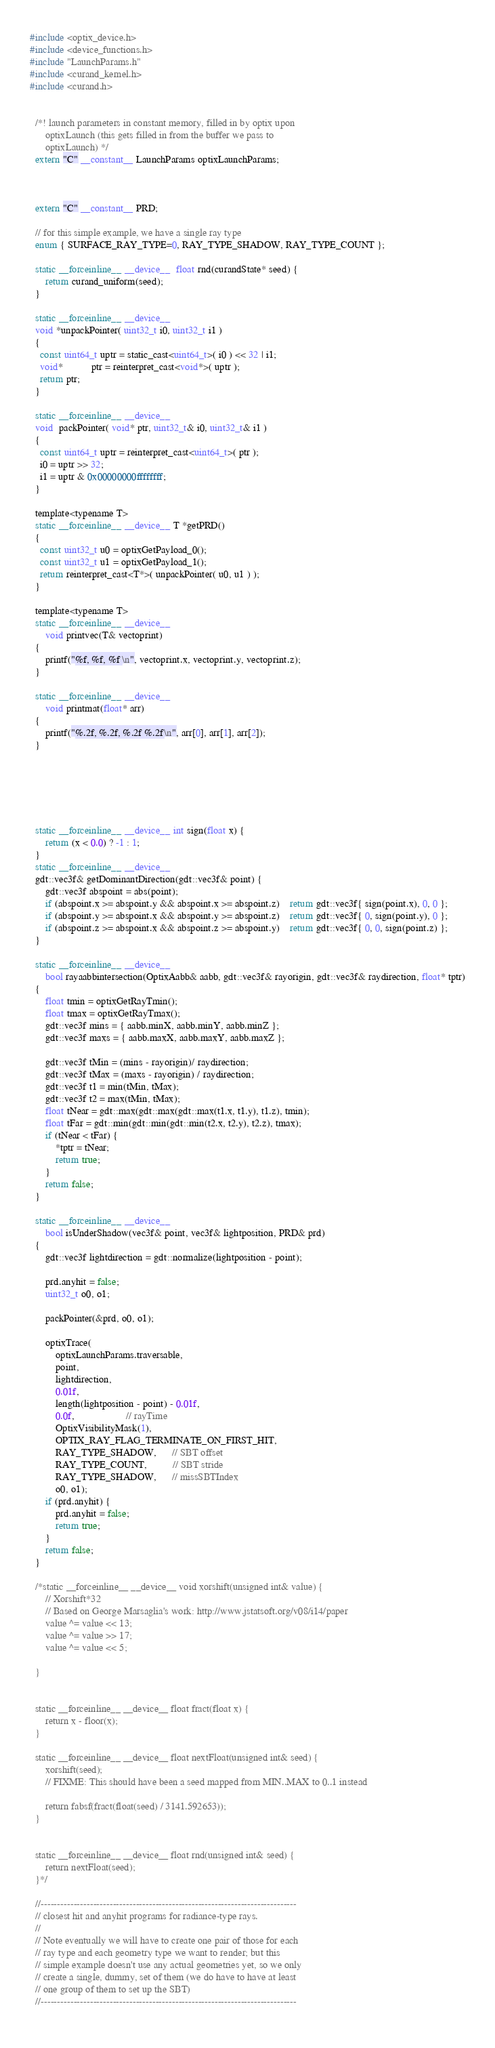Convert code to text. <code><loc_0><loc_0><loc_500><loc_500><_Cuda_>#include <optix_device.h>
#include <device_functions.h>
#include "LaunchParams.h"
#include <curand_kernel.h>
#include <curand.h>


  /*! launch parameters in constant memory, filled in by optix upon
      optixLaunch (this gets filled in from the buffer we pass to
      optixLaunch) */
  extern "C" __constant__ LaunchParams optixLaunchParams;

    

  extern "C" __constant__ PRD;

  // for this simple example, we have a single ray type
  enum { SURFACE_RAY_TYPE=0, RAY_TYPE_SHADOW, RAY_TYPE_COUNT };
  
  static __forceinline__ __device__  float rnd(curandState* seed) {
      return curand_uniform(seed);
  }
  
  static __forceinline__ __device__
  void *unpackPointer( uint32_t i0, uint32_t i1 )
  {
    const uint64_t uptr = static_cast<uint64_t>( i0 ) << 32 | i1;
    void*           ptr = reinterpret_cast<void*>( uptr ); 
    return ptr;
  }

  static __forceinline__ __device__
  void  packPointer( void* ptr, uint32_t& i0, uint32_t& i1 )
  {
    const uint64_t uptr = reinterpret_cast<uint64_t>( ptr );
    i0 = uptr >> 32;
    i1 = uptr & 0x00000000ffffffff;
  }

  template<typename T>
  static __forceinline__ __device__ T *getPRD()
  { 
    const uint32_t u0 = optixGetPayload_0();
    const uint32_t u1 = optixGetPayload_1();
    return reinterpret_cast<T*>( unpackPointer( u0, u1 ) );
  }
  
  template<typename T>
  static __forceinline__ __device__
      void printvec(T& vectoprint)
  {
      printf("%f, %f, %f \n", vectoprint.x, vectoprint.y, vectoprint.z);
  }

  static __forceinline__ __device__
      void printmat(float* arr)
  {
      printf("%.2f, %.2f, %.2f %.2f\n", arr[0], arr[1], arr[2]);
  }

 


  

  static __forceinline__ __device__ int sign(float x) {
      return (x < 0.0) ? -1 : 1;
  }
  static __forceinline__ __device__
  gdt::vec3f& getDominantDirection(gdt::vec3f& point) {
      gdt::vec3f abspoint = abs(point);
      if (abspoint.x >= abspoint.y && abspoint.x >= abspoint.z)    return gdt::vec3f{ sign(point.x), 0, 0 };
      if (abspoint.y >= abspoint.x && abspoint.y >= abspoint.z)    return gdt::vec3f{ 0, sign(point.y), 0 };
      if (abspoint.z >= abspoint.x && abspoint.z >= abspoint.y)    return gdt::vec3f{ 0, 0, sign(point.z) };
  }
  
  static __forceinline__ __device__
      bool rayaabbintersection(OptixAabb& aabb, gdt::vec3f& rayorigin, gdt::vec3f& raydirection, float* tptr)
  {
      float tmin = optixGetRayTmin();
      float tmax = optixGetRayTmax();
      gdt::vec3f mins = { aabb.minX, aabb.minY, aabb.minZ };
      gdt::vec3f maxs = { aabb.maxX, aabb.maxY, aabb.maxZ };

      gdt::vec3f tMin = (mins - rayorigin)/ raydirection;
      gdt::vec3f tMax = (maxs - rayorigin) / raydirection;
      gdt::vec3f t1 = min(tMin, tMax);
      gdt::vec3f t2 = max(tMin, tMax);
      float tNear = gdt::max(gdt::max(gdt::max(t1.x, t1.y), t1.z), tmin);
      float tFar = gdt::min(gdt::min(gdt::min(t2.x, t2.y), t2.z), tmax);
      if (tNear < tFar) {
          *tptr = tNear;
          return true;
      }
      return false;
  }

  static __forceinline__ __device__
      bool isUnderShadow(vec3f& point, vec3f& lightposition, PRD& prd)
  {
      gdt::vec3f lightdirection = gdt::normalize(lightposition - point);
     
      prd.anyhit = false;
      uint32_t o0, o1; 
     
      packPointer(&prd, o0, o1);
      
      optixTrace(
          optixLaunchParams.traversable,
          point,
          lightdirection,
          0.01f,
          length(lightposition - point) - 0.01f,
          0.0f,                    // rayTime
          OptixVisibilityMask(1),
          OPTIX_RAY_FLAG_TERMINATE_ON_FIRST_HIT,
          RAY_TYPE_SHADOW,      // SBT offset
          RAY_TYPE_COUNT,          // SBT stride
          RAY_TYPE_SHADOW,      // missSBTIndex
          o0, o1);
      if (prd.anyhit) {
          prd.anyhit = false;
          return true;
      }
      return false;
  }
  
  /*static __forceinline__ __device__ void xorshift(unsigned int& value) {
      // Xorshift*32
      // Based on George Marsaglia's work: http://www.jstatsoft.org/v08/i14/paper
      value ^= value << 13;
      value ^= value >> 17;
      value ^= value << 5;
      
  }

  
  static __forceinline__ __device__ float fract(float x) {
      return x - floor(x);
  }

  static __forceinline__ __device__ float nextFloat(unsigned int& seed) {
      xorshift(seed);
      // FIXME: This should have been a seed mapped from MIN..MAX to 0..1 instead
      
      return fabsf(fract(float(seed) / 3141.592653));
  }


  static __forceinline__ __device__ float rnd(unsigned int& seed) {
      return nextFloat(seed);
  }*/

  //------------------------------------------------------------------------------
  // closest hit and anyhit programs for radiance-type rays.
  //
  // Note eventually we will have to create one pair of those for each
  // ray type and each geometry type we want to render; but this
  // simple example doesn't use any actual geometries yet, so we only
  // create a single, dummy, set of them (we do have to have at least
  // one group of them to set up the SBT)
  //------------------------------------------------------------------------------
  </code> 